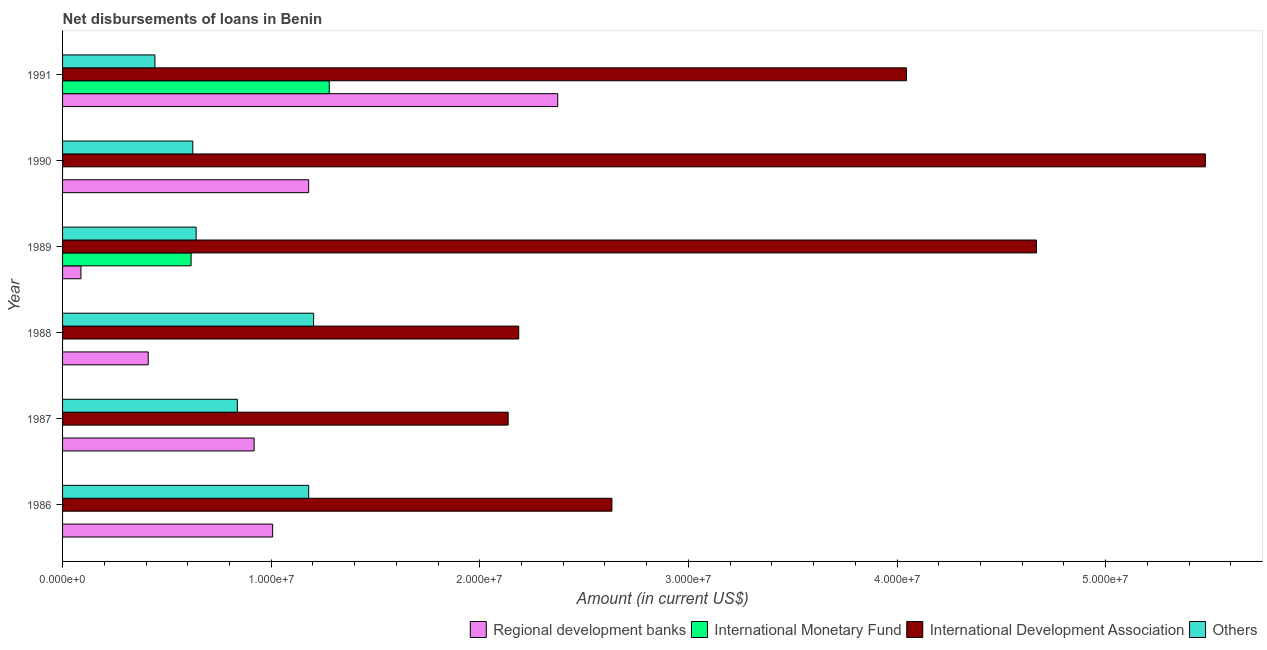How many different coloured bars are there?
Offer a very short reply. 4. How many groups of bars are there?
Your answer should be compact. 6. Are the number of bars per tick equal to the number of legend labels?
Give a very brief answer. No. How many bars are there on the 2nd tick from the top?
Provide a short and direct response. 3. What is the label of the 2nd group of bars from the top?
Offer a very short reply. 1990. In how many cases, is the number of bars for a given year not equal to the number of legend labels?
Your answer should be very brief. 4. What is the amount of loan disimbursed by other organisations in 1988?
Your response must be concise. 1.20e+07. Across all years, what is the maximum amount of loan disimbursed by international development association?
Offer a very short reply. 5.48e+07. What is the total amount of loan disimbursed by regional development banks in the graph?
Keep it short and to the point. 5.98e+07. What is the difference between the amount of loan disimbursed by international development association in 1988 and that in 1990?
Give a very brief answer. -3.29e+07. What is the difference between the amount of loan disimbursed by regional development banks in 1986 and the amount of loan disimbursed by other organisations in 1989?
Your response must be concise. 3.67e+06. What is the average amount of loan disimbursed by international monetary fund per year?
Provide a succinct answer. 3.16e+06. In the year 1986, what is the difference between the amount of loan disimbursed by other organisations and amount of loan disimbursed by international development association?
Your answer should be very brief. -1.45e+07. In how many years, is the amount of loan disimbursed by other organisations greater than 34000000 US$?
Your answer should be compact. 0. What is the ratio of the amount of loan disimbursed by other organisations in 1989 to that in 1990?
Your response must be concise. 1.02. Is the difference between the amount of loan disimbursed by regional development banks in 1989 and 1991 greater than the difference between the amount of loan disimbursed by other organisations in 1989 and 1991?
Your response must be concise. No. What is the difference between the highest and the second highest amount of loan disimbursed by international development association?
Offer a terse response. 8.10e+06. What is the difference between the highest and the lowest amount of loan disimbursed by regional development banks?
Provide a short and direct response. 2.29e+07. In how many years, is the amount of loan disimbursed by international development association greater than the average amount of loan disimbursed by international development association taken over all years?
Make the answer very short. 3. Is it the case that in every year, the sum of the amount of loan disimbursed by international monetary fund and amount of loan disimbursed by international development association is greater than the sum of amount of loan disimbursed by other organisations and amount of loan disimbursed by regional development banks?
Provide a succinct answer. Yes. Is it the case that in every year, the sum of the amount of loan disimbursed by regional development banks and amount of loan disimbursed by international monetary fund is greater than the amount of loan disimbursed by international development association?
Provide a succinct answer. No. How many bars are there?
Provide a short and direct response. 20. What is the difference between two consecutive major ticks on the X-axis?
Provide a short and direct response. 1.00e+07. Are the values on the major ticks of X-axis written in scientific E-notation?
Make the answer very short. Yes. Does the graph contain any zero values?
Provide a short and direct response. Yes. Where does the legend appear in the graph?
Keep it short and to the point. Bottom right. What is the title of the graph?
Your response must be concise. Net disbursements of loans in Benin. Does "Compensation of employees" appear as one of the legend labels in the graph?
Your answer should be very brief. No. What is the label or title of the X-axis?
Provide a short and direct response. Amount (in current US$). What is the label or title of the Y-axis?
Give a very brief answer. Year. What is the Amount (in current US$) in Regional development banks in 1986?
Your response must be concise. 1.01e+07. What is the Amount (in current US$) in International Monetary Fund in 1986?
Your answer should be very brief. 0. What is the Amount (in current US$) in International Development Association in 1986?
Offer a very short reply. 2.63e+07. What is the Amount (in current US$) in Others in 1986?
Provide a short and direct response. 1.18e+07. What is the Amount (in current US$) of Regional development banks in 1987?
Provide a short and direct response. 9.18e+06. What is the Amount (in current US$) in International Monetary Fund in 1987?
Provide a succinct answer. 0. What is the Amount (in current US$) of International Development Association in 1987?
Keep it short and to the point. 2.14e+07. What is the Amount (in current US$) of Others in 1987?
Offer a terse response. 8.38e+06. What is the Amount (in current US$) of Regional development banks in 1988?
Your response must be concise. 4.11e+06. What is the Amount (in current US$) in International Development Association in 1988?
Provide a short and direct response. 2.19e+07. What is the Amount (in current US$) in Others in 1988?
Keep it short and to the point. 1.20e+07. What is the Amount (in current US$) of Regional development banks in 1989?
Ensure brevity in your answer.  8.82e+05. What is the Amount (in current US$) of International Monetary Fund in 1989?
Keep it short and to the point. 6.16e+06. What is the Amount (in current US$) of International Development Association in 1989?
Provide a succinct answer. 4.67e+07. What is the Amount (in current US$) in Others in 1989?
Make the answer very short. 6.40e+06. What is the Amount (in current US$) of Regional development banks in 1990?
Give a very brief answer. 1.18e+07. What is the Amount (in current US$) in International Monetary Fund in 1990?
Your response must be concise. 0. What is the Amount (in current US$) of International Development Association in 1990?
Provide a succinct answer. 5.48e+07. What is the Amount (in current US$) of Others in 1990?
Your answer should be compact. 6.24e+06. What is the Amount (in current US$) of Regional development banks in 1991?
Provide a succinct answer. 2.37e+07. What is the Amount (in current US$) of International Monetary Fund in 1991?
Ensure brevity in your answer.  1.28e+07. What is the Amount (in current US$) of International Development Association in 1991?
Your answer should be compact. 4.05e+07. What is the Amount (in current US$) in Others in 1991?
Give a very brief answer. 4.43e+06. Across all years, what is the maximum Amount (in current US$) in Regional development banks?
Offer a terse response. 2.37e+07. Across all years, what is the maximum Amount (in current US$) in International Monetary Fund?
Keep it short and to the point. 1.28e+07. Across all years, what is the maximum Amount (in current US$) in International Development Association?
Give a very brief answer. 5.48e+07. Across all years, what is the maximum Amount (in current US$) in Others?
Your response must be concise. 1.20e+07. Across all years, what is the minimum Amount (in current US$) in Regional development banks?
Your answer should be very brief. 8.82e+05. Across all years, what is the minimum Amount (in current US$) of International Development Association?
Keep it short and to the point. 2.14e+07. Across all years, what is the minimum Amount (in current US$) of Others?
Give a very brief answer. 4.43e+06. What is the total Amount (in current US$) of Regional development banks in the graph?
Ensure brevity in your answer.  5.98e+07. What is the total Amount (in current US$) of International Monetary Fund in the graph?
Keep it short and to the point. 1.89e+07. What is the total Amount (in current US$) of International Development Association in the graph?
Your answer should be very brief. 2.11e+08. What is the total Amount (in current US$) of Others in the graph?
Offer a very short reply. 4.93e+07. What is the difference between the Amount (in current US$) of Regional development banks in 1986 and that in 1987?
Your response must be concise. 8.88e+05. What is the difference between the Amount (in current US$) in International Development Association in 1986 and that in 1987?
Provide a succinct answer. 4.97e+06. What is the difference between the Amount (in current US$) of Others in 1986 and that in 1987?
Provide a succinct answer. 3.42e+06. What is the difference between the Amount (in current US$) in Regional development banks in 1986 and that in 1988?
Provide a succinct answer. 5.96e+06. What is the difference between the Amount (in current US$) of International Development Association in 1986 and that in 1988?
Your response must be concise. 4.47e+06. What is the difference between the Amount (in current US$) in Others in 1986 and that in 1988?
Your answer should be compact. -2.36e+05. What is the difference between the Amount (in current US$) of Regional development banks in 1986 and that in 1989?
Your answer should be very brief. 9.19e+06. What is the difference between the Amount (in current US$) of International Development Association in 1986 and that in 1989?
Ensure brevity in your answer.  -2.04e+07. What is the difference between the Amount (in current US$) of Others in 1986 and that in 1989?
Keep it short and to the point. 5.40e+06. What is the difference between the Amount (in current US$) of Regional development banks in 1986 and that in 1990?
Your answer should be very brief. -1.73e+06. What is the difference between the Amount (in current US$) of International Development Association in 1986 and that in 1990?
Give a very brief answer. -2.84e+07. What is the difference between the Amount (in current US$) in Others in 1986 and that in 1990?
Offer a very short reply. 5.56e+06. What is the difference between the Amount (in current US$) in Regional development banks in 1986 and that in 1991?
Provide a short and direct response. -1.37e+07. What is the difference between the Amount (in current US$) of International Development Association in 1986 and that in 1991?
Your answer should be very brief. -1.41e+07. What is the difference between the Amount (in current US$) in Others in 1986 and that in 1991?
Provide a short and direct response. 7.37e+06. What is the difference between the Amount (in current US$) of Regional development banks in 1987 and that in 1988?
Provide a succinct answer. 5.08e+06. What is the difference between the Amount (in current US$) of International Development Association in 1987 and that in 1988?
Make the answer very short. -5.07e+05. What is the difference between the Amount (in current US$) in Others in 1987 and that in 1988?
Your response must be concise. -3.66e+06. What is the difference between the Amount (in current US$) of Regional development banks in 1987 and that in 1989?
Provide a short and direct response. 8.30e+06. What is the difference between the Amount (in current US$) of International Development Association in 1987 and that in 1989?
Your answer should be very brief. -2.53e+07. What is the difference between the Amount (in current US$) of Others in 1987 and that in 1989?
Provide a short and direct response. 1.98e+06. What is the difference between the Amount (in current US$) in Regional development banks in 1987 and that in 1990?
Provide a succinct answer. -2.61e+06. What is the difference between the Amount (in current US$) in International Development Association in 1987 and that in 1990?
Your answer should be compact. -3.34e+07. What is the difference between the Amount (in current US$) in Others in 1987 and that in 1990?
Offer a very short reply. 2.14e+06. What is the difference between the Amount (in current US$) of Regional development banks in 1987 and that in 1991?
Your answer should be compact. -1.46e+07. What is the difference between the Amount (in current US$) of International Development Association in 1987 and that in 1991?
Offer a very short reply. -1.91e+07. What is the difference between the Amount (in current US$) in Others in 1987 and that in 1991?
Give a very brief answer. 3.95e+06. What is the difference between the Amount (in current US$) of Regional development banks in 1988 and that in 1989?
Make the answer very short. 3.22e+06. What is the difference between the Amount (in current US$) in International Development Association in 1988 and that in 1989?
Give a very brief answer. -2.48e+07. What is the difference between the Amount (in current US$) in Others in 1988 and that in 1989?
Your response must be concise. 5.63e+06. What is the difference between the Amount (in current US$) of Regional development banks in 1988 and that in 1990?
Offer a very short reply. -7.69e+06. What is the difference between the Amount (in current US$) of International Development Association in 1988 and that in 1990?
Give a very brief answer. -3.29e+07. What is the difference between the Amount (in current US$) of Others in 1988 and that in 1990?
Offer a very short reply. 5.79e+06. What is the difference between the Amount (in current US$) of Regional development banks in 1988 and that in 1991?
Your answer should be very brief. -1.96e+07. What is the difference between the Amount (in current US$) in International Development Association in 1988 and that in 1991?
Provide a short and direct response. -1.86e+07. What is the difference between the Amount (in current US$) of Others in 1988 and that in 1991?
Keep it short and to the point. 7.61e+06. What is the difference between the Amount (in current US$) of Regional development banks in 1989 and that in 1990?
Your response must be concise. -1.09e+07. What is the difference between the Amount (in current US$) of International Development Association in 1989 and that in 1990?
Your answer should be compact. -8.10e+06. What is the difference between the Amount (in current US$) of Others in 1989 and that in 1990?
Offer a very short reply. 1.59e+05. What is the difference between the Amount (in current US$) in Regional development banks in 1989 and that in 1991?
Ensure brevity in your answer.  -2.29e+07. What is the difference between the Amount (in current US$) in International Monetary Fund in 1989 and that in 1991?
Provide a succinct answer. -6.62e+06. What is the difference between the Amount (in current US$) of International Development Association in 1989 and that in 1991?
Offer a terse response. 6.23e+06. What is the difference between the Amount (in current US$) of Others in 1989 and that in 1991?
Give a very brief answer. 1.98e+06. What is the difference between the Amount (in current US$) of Regional development banks in 1990 and that in 1991?
Give a very brief answer. -1.19e+07. What is the difference between the Amount (in current US$) in International Development Association in 1990 and that in 1991?
Your response must be concise. 1.43e+07. What is the difference between the Amount (in current US$) in Others in 1990 and that in 1991?
Provide a short and direct response. 1.82e+06. What is the difference between the Amount (in current US$) of Regional development banks in 1986 and the Amount (in current US$) of International Development Association in 1987?
Provide a short and direct response. -1.13e+07. What is the difference between the Amount (in current US$) of Regional development banks in 1986 and the Amount (in current US$) of Others in 1987?
Make the answer very short. 1.69e+06. What is the difference between the Amount (in current US$) in International Development Association in 1986 and the Amount (in current US$) in Others in 1987?
Your response must be concise. 1.80e+07. What is the difference between the Amount (in current US$) in Regional development banks in 1986 and the Amount (in current US$) in International Development Association in 1988?
Your response must be concise. -1.18e+07. What is the difference between the Amount (in current US$) of Regional development banks in 1986 and the Amount (in current US$) of Others in 1988?
Offer a terse response. -1.96e+06. What is the difference between the Amount (in current US$) of International Development Association in 1986 and the Amount (in current US$) of Others in 1988?
Ensure brevity in your answer.  1.43e+07. What is the difference between the Amount (in current US$) of Regional development banks in 1986 and the Amount (in current US$) of International Monetary Fund in 1989?
Your response must be concise. 3.91e+06. What is the difference between the Amount (in current US$) of Regional development banks in 1986 and the Amount (in current US$) of International Development Association in 1989?
Give a very brief answer. -3.66e+07. What is the difference between the Amount (in current US$) in Regional development banks in 1986 and the Amount (in current US$) in Others in 1989?
Give a very brief answer. 3.67e+06. What is the difference between the Amount (in current US$) in International Development Association in 1986 and the Amount (in current US$) in Others in 1989?
Make the answer very short. 1.99e+07. What is the difference between the Amount (in current US$) of Regional development banks in 1986 and the Amount (in current US$) of International Development Association in 1990?
Your response must be concise. -4.47e+07. What is the difference between the Amount (in current US$) of Regional development banks in 1986 and the Amount (in current US$) of Others in 1990?
Your answer should be compact. 3.83e+06. What is the difference between the Amount (in current US$) in International Development Association in 1986 and the Amount (in current US$) in Others in 1990?
Keep it short and to the point. 2.01e+07. What is the difference between the Amount (in current US$) of Regional development banks in 1986 and the Amount (in current US$) of International Monetary Fund in 1991?
Offer a very short reply. -2.71e+06. What is the difference between the Amount (in current US$) in Regional development banks in 1986 and the Amount (in current US$) in International Development Association in 1991?
Keep it short and to the point. -3.04e+07. What is the difference between the Amount (in current US$) of Regional development banks in 1986 and the Amount (in current US$) of Others in 1991?
Provide a succinct answer. 5.64e+06. What is the difference between the Amount (in current US$) in International Development Association in 1986 and the Amount (in current US$) in Others in 1991?
Your answer should be very brief. 2.19e+07. What is the difference between the Amount (in current US$) of Regional development banks in 1987 and the Amount (in current US$) of International Development Association in 1988?
Your answer should be compact. -1.27e+07. What is the difference between the Amount (in current US$) of Regional development banks in 1987 and the Amount (in current US$) of Others in 1988?
Keep it short and to the point. -2.85e+06. What is the difference between the Amount (in current US$) of International Development Association in 1987 and the Amount (in current US$) of Others in 1988?
Offer a terse response. 9.32e+06. What is the difference between the Amount (in current US$) in Regional development banks in 1987 and the Amount (in current US$) in International Monetary Fund in 1989?
Offer a very short reply. 3.02e+06. What is the difference between the Amount (in current US$) in Regional development banks in 1987 and the Amount (in current US$) in International Development Association in 1989?
Your answer should be very brief. -3.75e+07. What is the difference between the Amount (in current US$) of Regional development banks in 1987 and the Amount (in current US$) of Others in 1989?
Make the answer very short. 2.78e+06. What is the difference between the Amount (in current US$) of International Development Association in 1987 and the Amount (in current US$) of Others in 1989?
Your answer should be very brief. 1.50e+07. What is the difference between the Amount (in current US$) in Regional development banks in 1987 and the Amount (in current US$) in International Development Association in 1990?
Make the answer very short. -4.56e+07. What is the difference between the Amount (in current US$) of Regional development banks in 1987 and the Amount (in current US$) of Others in 1990?
Keep it short and to the point. 2.94e+06. What is the difference between the Amount (in current US$) of International Development Association in 1987 and the Amount (in current US$) of Others in 1990?
Make the answer very short. 1.51e+07. What is the difference between the Amount (in current US$) of Regional development banks in 1987 and the Amount (in current US$) of International Monetary Fund in 1991?
Offer a very short reply. -3.60e+06. What is the difference between the Amount (in current US$) of Regional development banks in 1987 and the Amount (in current US$) of International Development Association in 1991?
Offer a terse response. -3.13e+07. What is the difference between the Amount (in current US$) of Regional development banks in 1987 and the Amount (in current US$) of Others in 1991?
Give a very brief answer. 4.76e+06. What is the difference between the Amount (in current US$) in International Development Association in 1987 and the Amount (in current US$) in Others in 1991?
Your answer should be compact. 1.69e+07. What is the difference between the Amount (in current US$) in Regional development banks in 1988 and the Amount (in current US$) in International Monetary Fund in 1989?
Your answer should be very brief. -2.06e+06. What is the difference between the Amount (in current US$) in Regional development banks in 1988 and the Amount (in current US$) in International Development Association in 1989?
Your answer should be very brief. -4.26e+07. What is the difference between the Amount (in current US$) in Regional development banks in 1988 and the Amount (in current US$) in Others in 1989?
Provide a succinct answer. -2.30e+06. What is the difference between the Amount (in current US$) in International Development Association in 1988 and the Amount (in current US$) in Others in 1989?
Your answer should be very brief. 1.55e+07. What is the difference between the Amount (in current US$) of Regional development banks in 1988 and the Amount (in current US$) of International Development Association in 1990?
Your response must be concise. -5.07e+07. What is the difference between the Amount (in current US$) of Regional development banks in 1988 and the Amount (in current US$) of Others in 1990?
Offer a terse response. -2.14e+06. What is the difference between the Amount (in current US$) in International Development Association in 1988 and the Amount (in current US$) in Others in 1990?
Provide a short and direct response. 1.56e+07. What is the difference between the Amount (in current US$) in Regional development banks in 1988 and the Amount (in current US$) in International Monetary Fund in 1991?
Give a very brief answer. -8.68e+06. What is the difference between the Amount (in current US$) of Regional development banks in 1988 and the Amount (in current US$) of International Development Association in 1991?
Your answer should be compact. -3.63e+07. What is the difference between the Amount (in current US$) in Regional development banks in 1988 and the Amount (in current US$) in Others in 1991?
Make the answer very short. -3.19e+05. What is the difference between the Amount (in current US$) of International Development Association in 1988 and the Amount (in current US$) of Others in 1991?
Keep it short and to the point. 1.74e+07. What is the difference between the Amount (in current US$) of Regional development banks in 1989 and the Amount (in current US$) of International Development Association in 1990?
Offer a very short reply. -5.39e+07. What is the difference between the Amount (in current US$) in Regional development banks in 1989 and the Amount (in current US$) in Others in 1990?
Your answer should be compact. -5.36e+06. What is the difference between the Amount (in current US$) in International Monetary Fund in 1989 and the Amount (in current US$) in International Development Association in 1990?
Give a very brief answer. -4.86e+07. What is the difference between the Amount (in current US$) of International Monetary Fund in 1989 and the Amount (in current US$) of Others in 1990?
Ensure brevity in your answer.  -8.10e+04. What is the difference between the Amount (in current US$) of International Development Association in 1989 and the Amount (in current US$) of Others in 1990?
Provide a short and direct response. 4.04e+07. What is the difference between the Amount (in current US$) of Regional development banks in 1989 and the Amount (in current US$) of International Monetary Fund in 1991?
Provide a succinct answer. -1.19e+07. What is the difference between the Amount (in current US$) of Regional development banks in 1989 and the Amount (in current US$) of International Development Association in 1991?
Provide a short and direct response. -3.96e+07. What is the difference between the Amount (in current US$) in Regional development banks in 1989 and the Amount (in current US$) in Others in 1991?
Offer a terse response. -3.54e+06. What is the difference between the Amount (in current US$) in International Monetary Fund in 1989 and the Amount (in current US$) in International Development Association in 1991?
Keep it short and to the point. -3.43e+07. What is the difference between the Amount (in current US$) of International Monetary Fund in 1989 and the Amount (in current US$) of Others in 1991?
Your answer should be very brief. 1.74e+06. What is the difference between the Amount (in current US$) in International Development Association in 1989 and the Amount (in current US$) in Others in 1991?
Offer a very short reply. 4.23e+07. What is the difference between the Amount (in current US$) in Regional development banks in 1990 and the Amount (in current US$) in International Monetary Fund in 1991?
Your answer should be compact. -9.87e+05. What is the difference between the Amount (in current US$) in Regional development banks in 1990 and the Amount (in current US$) in International Development Association in 1991?
Your answer should be very brief. -2.87e+07. What is the difference between the Amount (in current US$) of Regional development banks in 1990 and the Amount (in current US$) of Others in 1991?
Offer a terse response. 7.37e+06. What is the difference between the Amount (in current US$) of International Development Association in 1990 and the Amount (in current US$) of Others in 1991?
Your response must be concise. 5.04e+07. What is the average Amount (in current US$) in Regional development banks per year?
Your response must be concise. 9.96e+06. What is the average Amount (in current US$) in International Monetary Fund per year?
Keep it short and to the point. 3.16e+06. What is the average Amount (in current US$) of International Development Association per year?
Provide a short and direct response. 3.52e+07. What is the average Amount (in current US$) of Others per year?
Ensure brevity in your answer.  8.21e+06. In the year 1986, what is the difference between the Amount (in current US$) of Regional development banks and Amount (in current US$) of International Development Association?
Ensure brevity in your answer.  -1.63e+07. In the year 1986, what is the difference between the Amount (in current US$) in Regional development banks and Amount (in current US$) in Others?
Ensure brevity in your answer.  -1.73e+06. In the year 1986, what is the difference between the Amount (in current US$) in International Development Association and Amount (in current US$) in Others?
Your answer should be compact. 1.45e+07. In the year 1987, what is the difference between the Amount (in current US$) in Regional development banks and Amount (in current US$) in International Development Association?
Offer a terse response. -1.22e+07. In the year 1987, what is the difference between the Amount (in current US$) in Regional development banks and Amount (in current US$) in Others?
Give a very brief answer. 8.04e+05. In the year 1987, what is the difference between the Amount (in current US$) in International Development Association and Amount (in current US$) in Others?
Provide a succinct answer. 1.30e+07. In the year 1988, what is the difference between the Amount (in current US$) in Regional development banks and Amount (in current US$) in International Development Association?
Make the answer very short. -1.78e+07. In the year 1988, what is the difference between the Amount (in current US$) of Regional development banks and Amount (in current US$) of Others?
Provide a short and direct response. -7.93e+06. In the year 1988, what is the difference between the Amount (in current US$) of International Development Association and Amount (in current US$) of Others?
Your answer should be very brief. 9.83e+06. In the year 1989, what is the difference between the Amount (in current US$) in Regional development banks and Amount (in current US$) in International Monetary Fund?
Your response must be concise. -5.28e+06. In the year 1989, what is the difference between the Amount (in current US$) of Regional development banks and Amount (in current US$) of International Development Association?
Your response must be concise. -4.58e+07. In the year 1989, what is the difference between the Amount (in current US$) in Regional development banks and Amount (in current US$) in Others?
Your answer should be very brief. -5.52e+06. In the year 1989, what is the difference between the Amount (in current US$) of International Monetary Fund and Amount (in current US$) of International Development Association?
Your answer should be very brief. -4.05e+07. In the year 1989, what is the difference between the Amount (in current US$) of International Monetary Fund and Amount (in current US$) of Others?
Provide a succinct answer. -2.40e+05. In the year 1989, what is the difference between the Amount (in current US$) in International Development Association and Amount (in current US$) in Others?
Ensure brevity in your answer.  4.03e+07. In the year 1990, what is the difference between the Amount (in current US$) of Regional development banks and Amount (in current US$) of International Development Association?
Your answer should be compact. -4.30e+07. In the year 1990, what is the difference between the Amount (in current US$) of Regional development banks and Amount (in current US$) of Others?
Your answer should be very brief. 5.55e+06. In the year 1990, what is the difference between the Amount (in current US$) in International Development Association and Amount (in current US$) in Others?
Ensure brevity in your answer.  4.85e+07. In the year 1991, what is the difference between the Amount (in current US$) of Regional development banks and Amount (in current US$) of International Monetary Fund?
Offer a terse response. 1.10e+07. In the year 1991, what is the difference between the Amount (in current US$) of Regional development banks and Amount (in current US$) of International Development Association?
Offer a very short reply. -1.67e+07. In the year 1991, what is the difference between the Amount (in current US$) of Regional development banks and Amount (in current US$) of Others?
Your response must be concise. 1.93e+07. In the year 1991, what is the difference between the Amount (in current US$) in International Monetary Fund and Amount (in current US$) in International Development Association?
Provide a succinct answer. -2.77e+07. In the year 1991, what is the difference between the Amount (in current US$) in International Monetary Fund and Amount (in current US$) in Others?
Offer a terse response. 8.36e+06. In the year 1991, what is the difference between the Amount (in current US$) of International Development Association and Amount (in current US$) of Others?
Offer a very short reply. 3.60e+07. What is the ratio of the Amount (in current US$) of Regional development banks in 1986 to that in 1987?
Offer a terse response. 1.1. What is the ratio of the Amount (in current US$) in International Development Association in 1986 to that in 1987?
Make the answer very short. 1.23. What is the ratio of the Amount (in current US$) of Others in 1986 to that in 1987?
Ensure brevity in your answer.  1.41. What is the ratio of the Amount (in current US$) of Regional development banks in 1986 to that in 1988?
Make the answer very short. 2.45. What is the ratio of the Amount (in current US$) of International Development Association in 1986 to that in 1988?
Give a very brief answer. 1.2. What is the ratio of the Amount (in current US$) in Others in 1986 to that in 1988?
Provide a succinct answer. 0.98. What is the ratio of the Amount (in current US$) of Regional development banks in 1986 to that in 1989?
Ensure brevity in your answer.  11.42. What is the ratio of the Amount (in current US$) in International Development Association in 1986 to that in 1989?
Offer a very short reply. 0.56. What is the ratio of the Amount (in current US$) of Others in 1986 to that in 1989?
Make the answer very short. 1.84. What is the ratio of the Amount (in current US$) of Regional development banks in 1986 to that in 1990?
Give a very brief answer. 0.85. What is the ratio of the Amount (in current US$) of International Development Association in 1986 to that in 1990?
Your answer should be very brief. 0.48. What is the ratio of the Amount (in current US$) of Others in 1986 to that in 1990?
Your answer should be very brief. 1.89. What is the ratio of the Amount (in current US$) of Regional development banks in 1986 to that in 1991?
Offer a very short reply. 0.42. What is the ratio of the Amount (in current US$) in International Development Association in 1986 to that in 1991?
Keep it short and to the point. 0.65. What is the ratio of the Amount (in current US$) in Others in 1986 to that in 1991?
Your answer should be very brief. 2.67. What is the ratio of the Amount (in current US$) in Regional development banks in 1987 to that in 1988?
Offer a terse response. 2.24. What is the ratio of the Amount (in current US$) in International Development Association in 1987 to that in 1988?
Offer a terse response. 0.98. What is the ratio of the Amount (in current US$) of Others in 1987 to that in 1988?
Provide a succinct answer. 0.7. What is the ratio of the Amount (in current US$) of Regional development banks in 1987 to that in 1989?
Make the answer very short. 10.41. What is the ratio of the Amount (in current US$) of International Development Association in 1987 to that in 1989?
Your answer should be very brief. 0.46. What is the ratio of the Amount (in current US$) of Others in 1987 to that in 1989?
Make the answer very short. 1.31. What is the ratio of the Amount (in current US$) in Regional development banks in 1987 to that in 1990?
Offer a very short reply. 0.78. What is the ratio of the Amount (in current US$) in International Development Association in 1987 to that in 1990?
Offer a very short reply. 0.39. What is the ratio of the Amount (in current US$) of Others in 1987 to that in 1990?
Make the answer very short. 1.34. What is the ratio of the Amount (in current US$) of Regional development banks in 1987 to that in 1991?
Offer a terse response. 0.39. What is the ratio of the Amount (in current US$) of International Development Association in 1987 to that in 1991?
Provide a succinct answer. 0.53. What is the ratio of the Amount (in current US$) of Others in 1987 to that in 1991?
Make the answer very short. 1.89. What is the ratio of the Amount (in current US$) of Regional development banks in 1988 to that in 1989?
Provide a succinct answer. 4.66. What is the ratio of the Amount (in current US$) of International Development Association in 1988 to that in 1989?
Offer a terse response. 0.47. What is the ratio of the Amount (in current US$) of Others in 1988 to that in 1989?
Provide a succinct answer. 1.88. What is the ratio of the Amount (in current US$) of Regional development banks in 1988 to that in 1990?
Provide a short and direct response. 0.35. What is the ratio of the Amount (in current US$) in International Development Association in 1988 to that in 1990?
Your response must be concise. 0.4. What is the ratio of the Amount (in current US$) of Others in 1988 to that in 1990?
Your answer should be very brief. 1.93. What is the ratio of the Amount (in current US$) of Regional development banks in 1988 to that in 1991?
Give a very brief answer. 0.17. What is the ratio of the Amount (in current US$) of International Development Association in 1988 to that in 1991?
Keep it short and to the point. 0.54. What is the ratio of the Amount (in current US$) in Others in 1988 to that in 1991?
Your answer should be compact. 2.72. What is the ratio of the Amount (in current US$) of Regional development banks in 1989 to that in 1990?
Make the answer very short. 0.07. What is the ratio of the Amount (in current US$) of International Development Association in 1989 to that in 1990?
Keep it short and to the point. 0.85. What is the ratio of the Amount (in current US$) of Others in 1989 to that in 1990?
Provide a succinct answer. 1.03. What is the ratio of the Amount (in current US$) in Regional development banks in 1989 to that in 1991?
Your answer should be compact. 0.04. What is the ratio of the Amount (in current US$) in International Monetary Fund in 1989 to that in 1991?
Your answer should be compact. 0.48. What is the ratio of the Amount (in current US$) in International Development Association in 1989 to that in 1991?
Ensure brevity in your answer.  1.15. What is the ratio of the Amount (in current US$) in Others in 1989 to that in 1991?
Your answer should be very brief. 1.45. What is the ratio of the Amount (in current US$) in Regional development banks in 1990 to that in 1991?
Make the answer very short. 0.5. What is the ratio of the Amount (in current US$) in International Development Association in 1990 to that in 1991?
Make the answer very short. 1.35. What is the ratio of the Amount (in current US$) of Others in 1990 to that in 1991?
Offer a terse response. 1.41. What is the difference between the highest and the second highest Amount (in current US$) in Regional development banks?
Offer a terse response. 1.19e+07. What is the difference between the highest and the second highest Amount (in current US$) of International Development Association?
Make the answer very short. 8.10e+06. What is the difference between the highest and the second highest Amount (in current US$) in Others?
Make the answer very short. 2.36e+05. What is the difference between the highest and the lowest Amount (in current US$) of Regional development banks?
Your answer should be compact. 2.29e+07. What is the difference between the highest and the lowest Amount (in current US$) of International Monetary Fund?
Provide a short and direct response. 1.28e+07. What is the difference between the highest and the lowest Amount (in current US$) in International Development Association?
Keep it short and to the point. 3.34e+07. What is the difference between the highest and the lowest Amount (in current US$) in Others?
Offer a very short reply. 7.61e+06. 